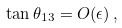Convert formula to latex. <formula><loc_0><loc_0><loc_500><loc_500>\tan \theta _ { 1 3 } = O ( \epsilon ) \, ,</formula> 